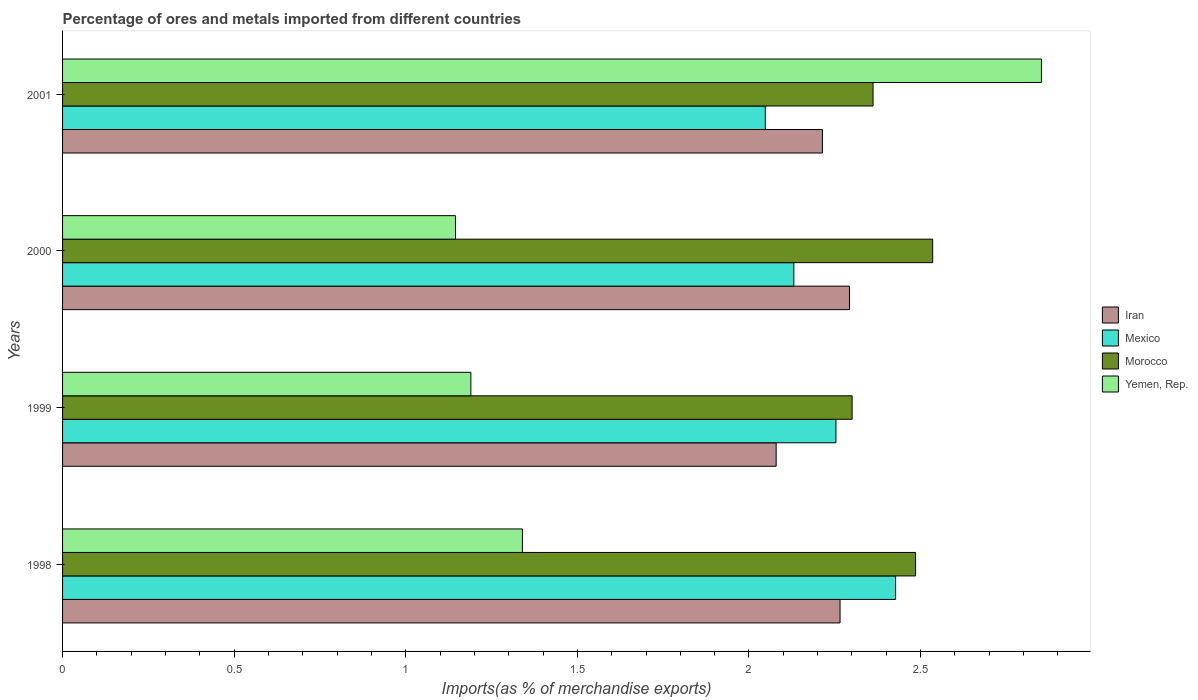How many bars are there on the 3rd tick from the bottom?
Provide a short and direct response. 4. In how many cases, is the number of bars for a given year not equal to the number of legend labels?
Provide a succinct answer. 0. What is the percentage of imports to different countries in Iran in 1999?
Offer a terse response. 2.08. Across all years, what is the maximum percentage of imports to different countries in Iran?
Offer a very short reply. 2.29. Across all years, what is the minimum percentage of imports to different countries in Mexico?
Give a very brief answer. 2.05. What is the total percentage of imports to different countries in Morocco in the graph?
Your response must be concise. 9.68. What is the difference between the percentage of imports to different countries in Iran in 1998 and that in 1999?
Provide a succinct answer. 0.19. What is the difference between the percentage of imports to different countries in Mexico in 2000 and the percentage of imports to different countries in Morocco in 2001?
Your answer should be very brief. -0.23. What is the average percentage of imports to different countries in Morocco per year?
Give a very brief answer. 2.42. In the year 2000, what is the difference between the percentage of imports to different countries in Iran and percentage of imports to different countries in Morocco?
Your answer should be compact. -0.24. In how many years, is the percentage of imports to different countries in Yemen, Rep. greater than 1.5 %?
Provide a short and direct response. 1. What is the ratio of the percentage of imports to different countries in Yemen, Rep. in 2000 to that in 2001?
Your response must be concise. 0.4. Is the percentage of imports to different countries in Mexico in 1999 less than that in 2000?
Ensure brevity in your answer.  No. Is the difference between the percentage of imports to different countries in Iran in 1998 and 1999 greater than the difference between the percentage of imports to different countries in Morocco in 1998 and 1999?
Provide a succinct answer. Yes. What is the difference between the highest and the second highest percentage of imports to different countries in Morocco?
Make the answer very short. 0.05. What is the difference between the highest and the lowest percentage of imports to different countries in Mexico?
Give a very brief answer. 0.38. In how many years, is the percentage of imports to different countries in Mexico greater than the average percentage of imports to different countries in Mexico taken over all years?
Provide a short and direct response. 2. What does the 2nd bar from the top in 1998 represents?
Keep it short and to the point. Morocco. What does the 3rd bar from the bottom in 1998 represents?
Offer a terse response. Morocco. How many bars are there?
Offer a very short reply. 16. Does the graph contain any zero values?
Offer a terse response. No. Does the graph contain grids?
Provide a succinct answer. No. How many legend labels are there?
Offer a very short reply. 4. How are the legend labels stacked?
Your answer should be compact. Vertical. What is the title of the graph?
Your response must be concise. Percentage of ores and metals imported from different countries. What is the label or title of the X-axis?
Ensure brevity in your answer.  Imports(as % of merchandise exports). What is the Imports(as % of merchandise exports) of Iran in 1998?
Offer a terse response. 2.27. What is the Imports(as % of merchandise exports) in Mexico in 1998?
Your answer should be very brief. 2.43. What is the Imports(as % of merchandise exports) of Morocco in 1998?
Offer a terse response. 2.49. What is the Imports(as % of merchandise exports) of Yemen, Rep. in 1998?
Provide a succinct answer. 1.34. What is the Imports(as % of merchandise exports) in Iran in 1999?
Make the answer very short. 2.08. What is the Imports(as % of merchandise exports) in Mexico in 1999?
Provide a short and direct response. 2.25. What is the Imports(as % of merchandise exports) of Morocco in 1999?
Offer a terse response. 2.3. What is the Imports(as % of merchandise exports) in Yemen, Rep. in 1999?
Provide a short and direct response. 1.19. What is the Imports(as % of merchandise exports) of Iran in 2000?
Ensure brevity in your answer.  2.29. What is the Imports(as % of merchandise exports) in Mexico in 2000?
Keep it short and to the point. 2.13. What is the Imports(as % of merchandise exports) of Morocco in 2000?
Offer a terse response. 2.54. What is the Imports(as % of merchandise exports) of Yemen, Rep. in 2000?
Offer a very short reply. 1.14. What is the Imports(as % of merchandise exports) in Iran in 2001?
Keep it short and to the point. 2.21. What is the Imports(as % of merchandise exports) in Mexico in 2001?
Your answer should be very brief. 2.05. What is the Imports(as % of merchandise exports) of Morocco in 2001?
Your answer should be very brief. 2.36. What is the Imports(as % of merchandise exports) in Yemen, Rep. in 2001?
Offer a terse response. 2.85. Across all years, what is the maximum Imports(as % of merchandise exports) of Iran?
Keep it short and to the point. 2.29. Across all years, what is the maximum Imports(as % of merchandise exports) of Mexico?
Provide a short and direct response. 2.43. Across all years, what is the maximum Imports(as % of merchandise exports) of Morocco?
Offer a terse response. 2.54. Across all years, what is the maximum Imports(as % of merchandise exports) of Yemen, Rep.?
Provide a succinct answer. 2.85. Across all years, what is the minimum Imports(as % of merchandise exports) in Iran?
Your answer should be compact. 2.08. Across all years, what is the minimum Imports(as % of merchandise exports) in Mexico?
Make the answer very short. 2.05. Across all years, what is the minimum Imports(as % of merchandise exports) of Morocco?
Ensure brevity in your answer.  2.3. Across all years, what is the minimum Imports(as % of merchandise exports) of Yemen, Rep.?
Your answer should be compact. 1.14. What is the total Imports(as % of merchandise exports) of Iran in the graph?
Provide a succinct answer. 8.85. What is the total Imports(as % of merchandise exports) in Mexico in the graph?
Ensure brevity in your answer.  8.86. What is the total Imports(as % of merchandise exports) in Morocco in the graph?
Provide a short and direct response. 9.68. What is the total Imports(as % of merchandise exports) of Yemen, Rep. in the graph?
Ensure brevity in your answer.  6.53. What is the difference between the Imports(as % of merchandise exports) of Iran in 1998 and that in 1999?
Your answer should be compact. 0.19. What is the difference between the Imports(as % of merchandise exports) in Mexico in 1998 and that in 1999?
Provide a short and direct response. 0.17. What is the difference between the Imports(as % of merchandise exports) in Morocco in 1998 and that in 1999?
Offer a very short reply. 0.18. What is the difference between the Imports(as % of merchandise exports) of Yemen, Rep. in 1998 and that in 1999?
Offer a terse response. 0.15. What is the difference between the Imports(as % of merchandise exports) of Iran in 1998 and that in 2000?
Your answer should be compact. -0.03. What is the difference between the Imports(as % of merchandise exports) in Mexico in 1998 and that in 2000?
Ensure brevity in your answer.  0.3. What is the difference between the Imports(as % of merchandise exports) in Morocco in 1998 and that in 2000?
Make the answer very short. -0.05. What is the difference between the Imports(as % of merchandise exports) in Yemen, Rep. in 1998 and that in 2000?
Your answer should be very brief. 0.2. What is the difference between the Imports(as % of merchandise exports) in Iran in 1998 and that in 2001?
Your response must be concise. 0.05. What is the difference between the Imports(as % of merchandise exports) of Mexico in 1998 and that in 2001?
Offer a very short reply. 0.38. What is the difference between the Imports(as % of merchandise exports) in Morocco in 1998 and that in 2001?
Give a very brief answer. 0.12. What is the difference between the Imports(as % of merchandise exports) in Yemen, Rep. in 1998 and that in 2001?
Ensure brevity in your answer.  -1.51. What is the difference between the Imports(as % of merchandise exports) in Iran in 1999 and that in 2000?
Your answer should be very brief. -0.21. What is the difference between the Imports(as % of merchandise exports) in Mexico in 1999 and that in 2000?
Your answer should be very brief. 0.12. What is the difference between the Imports(as % of merchandise exports) in Morocco in 1999 and that in 2000?
Keep it short and to the point. -0.23. What is the difference between the Imports(as % of merchandise exports) in Yemen, Rep. in 1999 and that in 2000?
Offer a very short reply. 0.04. What is the difference between the Imports(as % of merchandise exports) of Iran in 1999 and that in 2001?
Ensure brevity in your answer.  -0.13. What is the difference between the Imports(as % of merchandise exports) of Mexico in 1999 and that in 2001?
Offer a terse response. 0.21. What is the difference between the Imports(as % of merchandise exports) in Morocco in 1999 and that in 2001?
Give a very brief answer. -0.06. What is the difference between the Imports(as % of merchandise exports) in Yemen, Rep. in 1999 and that in 2001?
Provide a succinct answer. -1.66. What is the difference between the Imports(as % of merchandise exports) of Iran in 2000 and that in 2001?
Provide a succinct answer. 0.08. What is the difference between the Imports(as % of merchandise exports) in Mexico in 2000 and that in 2001?
Offer a terse response. 0.08. What is the difference between the Imports(as % of merchandise exports) in Morocco in 2000 and that in 2001?
Keep it short and to the point. 0.17. What is the difference between the Imports(as % of merchandise exports) in Yemen, Rep. in 2000 and that in 2001?
Provide a short and direct response. -1.71. What is the difference between the Imports(as % of merchandise exports) in Iran in 1998 and the Imports(as % of merchandise exports) in Mexico in 1999?
Your answer should be very brief. 0.01. What is the difference between the Imports(as % of merchandise exports) in Iran in 1998 and the Imports(as % of merchandise exports) in Morocco in 1999?
Make the answer very short. -0.04. What is the difference between the Imports(as % of merchandise exports) in Iran in 1998 and the Imports(as % of merchandise exports) in Yemen, Rep. in 1999?
Your answer should be compact. 1.08. What is the difference between the Imports(as % of merchandise exports) in Mexico in 1998 and the Imports(as % of merchandise exports) in Morocco in 1999?
Offer a terse response. 0.13. What is the difference between the Imports(as % of merchandise exports) in Mexico in 1998 and the Imports(as % of merchandise exports) in Yemen, Rep. in 1999?
Make the answer very short. 1.24. What is the difference between the Imports(as % of merchandise exports) in Morocco in 1998 and the Imports(as % of merchandise exports) in Yemen, Rep. in 1999?
Provide a short and direct response. 1.3. What is the difference between the Imports(as % of merchandise exports) of Iran in 1998 and the Imports(as % of merchandise exports) of Mexico in 2000?
Provide a short and direct response. 0.13. What is the difference between the Imports(as % of merchandise exports) in Iran in 1998 and the Imports(as % of merchandise exports) in Morocco in 2000?
Offer a very short reply. -0.27. What is the difference between the Imports(as % of merchandise exports) of Iran in 1998 and the Imports(as % of merchandise exports) of Yemen, Rep. in 2000?
Your answer should be compact. 1.12. What is the difference between the Imports(as % of merchandise exports) in Mexico in 1998 and the Imports(as % of merchandise exports) in Morocco in 2000?
Offer a terse response. -0.11. What is the difference between the Imports(as % of merchandise exports) in Mexico in 1998 and the Imports(as % of merchandise exports) in Yemen, Rep. in 2000?
Offer a terse response. 1.28. What is the difference between the Imports(as % of merchandise exports) in Morocco in 1998 and the Imports(as % of merchandise exports) in Yemen, Rep. in 2000?
Keep it short and to the point. 1.34. What is the difference between the Imports(as % of merchandise exports) of Iran in 1998 and the Imports(as % of merchandise exports) of Mexico in 2001?
Your answer should be compact. 0.22. What is the difference between the Imports(as % of merchandise exports) in Iran in 1998 and the Imports(as % of merchandise exports) in Morocco in 2001?
Offer a terse response. -0.1. What is the difference between the Imports(as % of merchandise exports) of Iran in 1998 and the Imports(as % of merchandise exports) of Yemen, Rep. in 2001?
Keep it short and to the point. -0.59. What is the difference between the Imports(as % of merchandise exports) of Mexico in 1998 and the Imports(as % of merchandise exports) of Morocco in 2001?
Offer a terse response. 0.07. What is the difference between the Imports(as % of merchandise exports) in Mexico in 1998 and the Imports(as % of merchandise exports) in Yemen, Rep. in 2001?
Give a very brief answer. -0.42. What is the difference between the Imports(as % of merchandise exports) of Morocco in 1998 and the Imports(as % of merchandise exports) of Yemen, Rep. in 2001?
Provide a short and direct response. -0.37. What is the difference between the Imports(as % of merchandise exports) in Iran in 1999 and the Imports(as % of merchandise exports) in Mexico in 2000?
Make the answer very short. -0.05. What is the difference between the Imports(as % of merchandise exports) in Iran in 1999 and the Imports(as % of merchandise exports) in Morocco in 2000?
Ensure brevity in your answer.  -0.46. What is the difference between the Imports(as % of merchandise exports) of Iran in 1999 and the Imports(as % of merchandise exports) of Yemen, Rep. in 2000?
Ensure brevity in your answer.  0.93. What is the difference between the Imports(as % of merchandise exports) in Mexico in 1999 and the Imports(as % of merchandise exports) in Morocco in 2000?
Your response must be concise. -0.28. What is the difference between the Imports(as % of merchandise exports) of Mexico in 1999 and the Imports(as % of merchandise exports) of Yemen, Rep. in 2000?
Your answer should be compact. 1.11. What is the difference between the Imports(as % of merchandise exports) in Morocco in 1999 and the Imports(as % of merchandise exports) in Yemen, Rep. in 2000?
Provide a short and direct response. 1.16. What is the difference between the Imports(as % of merchandise exports) in Iran in 1999 and the Imports(as % of merchandise exports) in Mexico in 2001?
Your answer should be very brief. 0.03. What is the difference between the Imports(as % of merchandise exports) in Iran in 1999 and the Imports(as % of merchandise exports) in Morocco in 2001?
Offer a terse response. -0.28. What is the difference between the Imports(as % of merchandise exports) of Iran in 1999 and the Imports(as % of merchandise exports) of Yemen, Rep. in 2001?
Provide a short and direct response. -0.77. What is the difference between the Imports(as % of merchandise exports) of Mexico in 1999 and the Imports(as % of merchandise exports) of Morocco in 2001?
Give a very brief answer. -0.11. What is the difference between the Imports(as % of merchandise exports) of Mexico in 1999 and the Imports(as % of merchandise exports) of Yemen, Rep. in 2001?
Your answer should be compact. -0.6. What is the difference between the Imports(as % of merchandise exports) in Morocco in 1999 and the Imports(as % of merchandise exports) in Yemen, Rep. in 2001?
Provide a succinct answer. -0.55. What is the difference between the Imports(as % of merchandise exports) of Iran in 2000 and the Imports(as % of merchandise exports) of Mexico in 2001?
Provide a succinct answer. 0.25. What is the difference between the Imports(as % of merchandise exports) in Iran in 2000 and the Imports(as % of merchandise exports) in Morocco in 2001?
Provide a succinct answer. -0.07. What is the difference between the Imports(as % of merchandise exports) in Iran in 2000 and the Imports(as % of merchandise exports) in Yemen, Rep. in 2001?
Ensure brevity in your answer.  -0.56. What is the difference between the Imports(as % of merchandise exports) in Mexico in 2000 and the Imports(as % of merchandise exports) in Morocco in 2001?
Keep it short and to the point. -0.23. What is the difference between the Imports(as % of merchandise exports) in Mexico in 2000 and the Imports(as % of merchandise exports) in Yemen, Rep. in 2001?
Provide a short and direct response. -0.72. What is the difference between the Imports(as % of merchandise exports) of Morocco in 2000 and the Imports(as % of merchandise exports) of Yemen, Rep. in 2001?
Your response must be concise. -0.32. What is the average Imports(as % of merchandise exports) of Iran per year?
Offer a very short reply. 2.21. What is the average Imports(as % of merchandise exports) in Mexico per year?
Keep it short and to the point. 2.21. What is the average Imports(as % of merchandise exports) of Morocco per year?
Offer a terse response. 2.42. What is the average Imports(as % of merchandise exports) in Yemen, Rep. per year?
Give a very brief answer. 1.63. In the year 1998, what is the difference between the Imports(as % of merchandise exports) in Iran and Imports(as % of merchandise exports) in Mexico?
Ensure brevity in your answer.  -0.16. In the year 1998, what is the difference between the Imports(as % of merchandise exports) of Iran and Imports(as % of merchandise exports) of Morocco?
Offer a terse response. -0.22. In the year 1998, what is the difference between the Imports(as % of merchandise exports) in Iran and Imports(as % of merchandise exports) in Yemen, Rep.?
Make the answer very short. 0.93. In the year 1998, what is the difference between the Imports(as % of merchandise exports) of Mexico and Imports(as % of merchandise exports) of Morocco?
Keep it short and to the point. -0.06. In the year 1998, what is the difference between the Imports(as % of merchandise exports) of Mexico and Imports(as % of merchandise exports) of Yemen, Rep.?
Your response must be concise. 1.09. In the year 1998, what is the difference between the Imports(as % of merchandise exports) of Morocco and Imports(as % of merchandise exports) of Yemen, Rep.?
Keep it short and to the point. 1.15. In the year 1999, what is the difference between the Imports(as % of merchandise exports) of Iran and Imports(as % of merchandise exports) of Mexico?
Offer a terse response. -0.17. In the year 1999, what is the difference between the Imports(as % of merchandise exports) in Iran and Imports(as % of merchandise exports) in Morocco?
Provide a succinct answer. -0.22. In the year 1999, what is the difference between the Imports(as % of merchandise exports) of Iran and Imports(as % of merchandise exports) of Yemen, Rep.?
Your response must be concise. 0.89. In the year 1999, what is the difference between the Imports(as % of merchandise exports) in Mexico and Imports(as % of merchandise exports) in Morocco?
Keep it short and to the point. -0.05. In the year 1999, what is the difference between the Imports(as % of merchandise exports) of Mexico and Imports(as % of merchandise exports) of Yemen, Rep.?
Make the answer very short. 1.06. In the year 1999, what is the difference between the Imports(as % of merchandise exports) in Morocco and Imports(as % of merchandise exports) in Yemen, Rep.?
Your answer should be very brief. 1.11. In the year 2000, what is the difference between the Imports(as % of merchandise exports) of Iran and Imports(as % of merchandise exports) of Mexico?
Your answer should be compact. 0.16. In the year 2000, what is the difference between the Imports(as % of merchandise exports) in Iran and Imports(as % of merchandise exports) in Morocco?
Ensure brevity in your answer.  -0.24. In the year 2000, what is the difference between the Imports(as % of merchandise exports) in Iran and Imports(as % of merchandise exports) in Yemen, Rep.?
Provide a succinct answer. 1.15. In the year 2000, what is the difference between the Imports(as % of merchandise exports) of Mexico and Imports(as % of merchandise exports) of Morocco?
Your response must be concise. -0.4. In the year 2000, what is the difference between the Imports(as % of merchandise exports) in Mexico and Imports(as % of merchandise exports) in Yemen, Rep.?
Offer a terse response. 0.99. In the year 2000, what is the difference between the Imports(as % of merchandise exports) of Morocco and Imports(as % of merchandise exports) of Yemen, Rep.?
Your answer should be very brief. 1.39. In the year 2001, what is the difference between the Imports(as % of merchandise exports) of Iran and Imports(as % of merchandise exports) of Mexico?
Make the answer very short. 0.17. In the year 2001, what is the difference between the Imports(as % of merchandise exports) of Iran and Imports(as % of merchandise exports) of Morocco?
Ensure brevity in your answer.  -0.15. In the year 2001, what is the difference between the Imports(as % of merchandise exports) of Iran and Imports(as % of merchandise exports) of Yemen, Rep.?
Your answer should be very brief. -0.64. In the year 2001, what is the difference between the Imports(as % of merchandise exports) in Mexico and Imports(as % of merchandise exports) in Morocco?
Your answer should be compact. -0.31. In the year 2001, what is the difference between the Imports(as % of merchandise exports) in Mexico and Imports(as % of merchandise exports) in Yemen, Rep.?
Your answer should be very brief. -0.8. In the year 2001, what is the difference between the Imports(as % of merchandise exports) of Morocco and Imports(as % of merchandise exports) of Yemen, Rep.?
Provide a short and direct response. -0.49. What is the ratio of the Imports(as % of merchandise exports) of Iran in 1998 to that in 1999?
Offer a very short reply. 1.09. What is the ratio of the Imports(as % of merchandise exports) in Mexico in 1998 to that in 1999?
Ensure brevity in your answer.  1.08. What is the ratio of the Imports(as % of merchandise exports) in Morocco in 1998 to that in 1999?
Offer a very short reply. 1.08. What is the ratio of the Imports(as % of merchandise exports) in Yemen, Rep. in 1998 to that in 1999?
Give a very brief answer. 1.13. What is the ratio of the Imports(as % of merchandise exports) in Iran in 1998 to that in 2000?
Provide a succinct answer. 0.99. What is the ratio of the Imports(as % of merchandise exports) in Mexico in 1998 to that in 2000?
Offer a very short reply. 1.14. What is the ratio of the Imports(as % of merchandise exports) of Morocco in 1998 to that in 2000?
Keep it short and to the point. 0.98. What is the ratio of the Imports(as % of merchandise exports) of Yemen, Rep. in 1998 to that in 2000?
Your response must be concise. 1.17. What is the ratio of the Imports(as % of merchandise exports) of Iran in 1998 to that in 2001?
Provide a short and direct response. 1.02. What is the ratio of the Imports(as % of merchandise exports) in Mexico in 1998 to that in 2001?
Make the answer very short. 1.19. What is the ratio of the Imports(as % of merchandise exports) in Morocco in 1998 to that in 2001?
Provide a succinct answer. 1.05. What is the ratio of the Imports(as % of merchandise exports) of Yemen, Rep. in 1998 to that in 2001?
Provide a succinct answer. 0.47. What is the ratio of the Imports(as % of merchandise exports) in Iran in 1999 to that in 2000?
Offer a very short reply. 0.91. What is the ratio of the Imports(as % of merchandise exports) in Mexico in 1999 to that in 2000?
Give a very brief answer. 1.06. What is the ratio of the Imports(as % of merchandise exports) of Morocco in 1999 to that in 2000?
Offer a terse response. 0.91. What is the ratio of the Imports(as % of merchandise exports) in Yemen, Rep. in 1999 to that in 2000?
Keep it short and to the point. 1.04. What is the ratio of the Imports(as % of merchandise exports) in Iran in 1999 to that in 2001?
Provide a succinct answer. 0.94. What is the ratio of the Imports(as % of merchandise exports) of Mexico in 1999 to that in 2001?
Give a very brief answer. 1.1. What is the ratio of the Imports(as % of merchandise exports) of Morocco in 1999 to that in 2001?
Your answer should be very brief. 0.97. What is the ratio of the Imports(as % of merchandise exports) in Yemen, Rep. in 1999 to that in 2001?
Offer a terse response. 0.42. What is the ratio of the Imports(as % of merchandise exports) in Iran in 2000 to that in 2001?
Offer a terse response. 1.04. What is the ratio of the Imports(as % of merchandise exports) of Mexico in 2000 to that in 2001?
Provide a short and direct response. 1.04. What is the ratio of the Imports(as % of merchandise exports) in Morocco in 2000 to that in 2001?
Your answer should be very brief. 1.07. What is the ratio of the Imports(as % of merchandise exports) of Yemen, Rep. in 2000 to that in 2001?
Offer a terse response. 0.4. What is the difference between the highest and the second highest Imports(as % of merchandise exports) of Iran?
Offer a terse response. 0.03. What is the difference between the highest and the second highest Imports(as % of merchandise exports) in Mexico?
Your response must be concise. 0.17. What is the difference between the highest and the second highest Imports(as % of merchandise exports) of Morocco?
Offer a very short reply. 0.05. What is the difference between the highest and the second highest Imports(as % of merchandise exports) of Yemen, Rep.?
Provide a succinct answer. 1.51. What is the difference between the highest and the lowest Imports(as % of merchandise exports) of Iran?
Ensure brevity in your answer.  0.21. What is the difference between the highest and the lowest Imports(as % of merchandise exports) in Mexico?
Make the answer very short. 0.38. What is the difference between the highest and the lowest Imports(as % of merchandise exports) in Morocco?
Your response must be concise. 0.23. What is the difference between the highest and the lowest Imports(as % of merchandise exports) of Yemen, Rep.?
Provide a succinct answer. 1.71. 